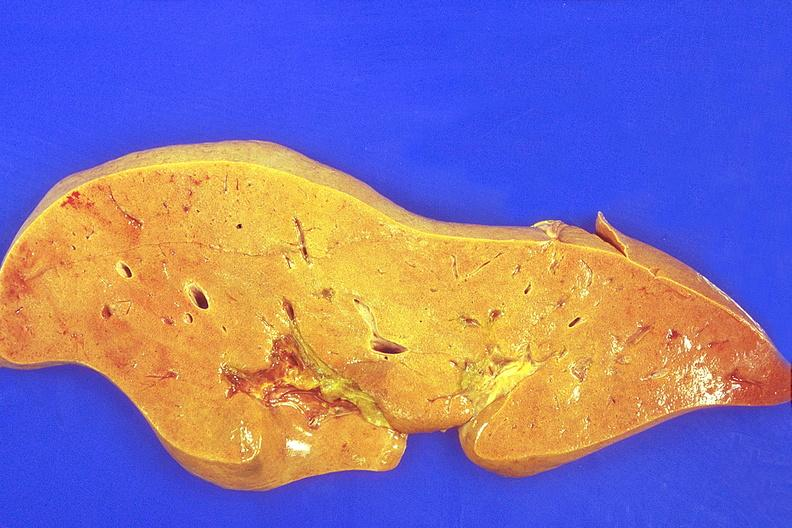s hepatobiliary present?
Answer the question using a single word or phrase. Yes 